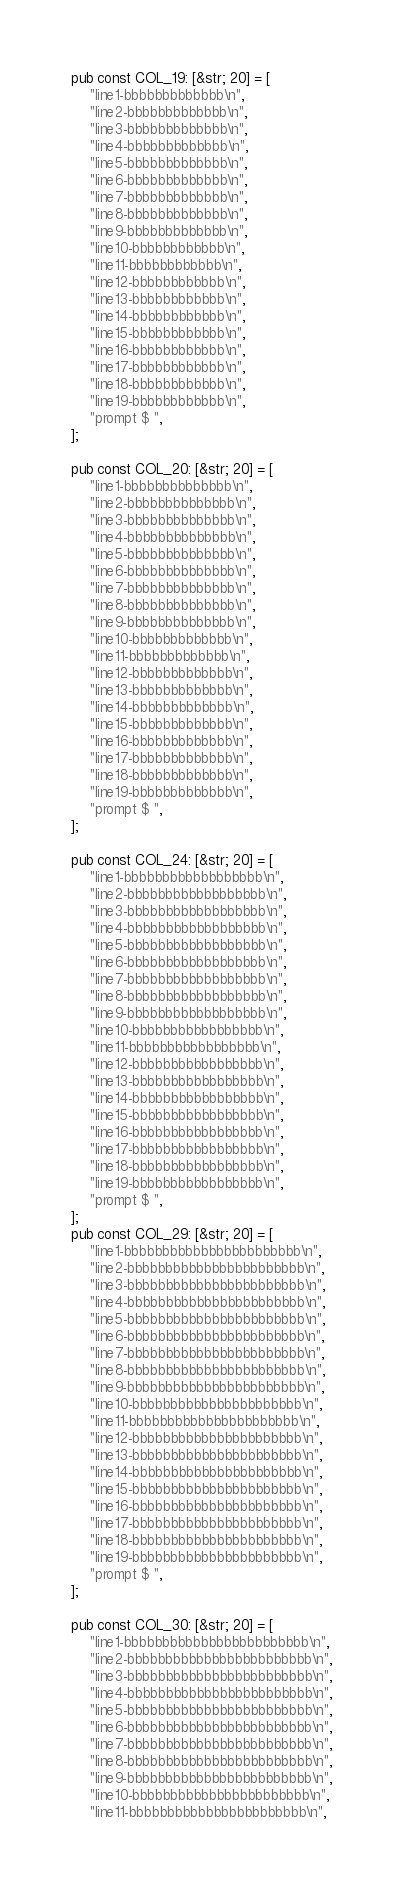<code> <loc_0><loc_0><loc_500><loc_500><_Rust_>
pub const COL_19: [&str; 20] = [
    "line1-bbbbbbbbbbbbb\n",
    "line2-bbbbbbbbbbbbb\n",
    "line3-bbbbbbbbbbbbb\n",
    "line4-bbbbbbbbbbbbb\n",
    "line5-bbbbbbbbbbbbb\n",
    "line6-bbbbbbbbbbbbb\n",
    "line7-bbbbbbbbbbbbb\n",
    "line8-bbbbbbbbbbbbb\n",
    "line9-bbbbbbbbbbbbb\n",
    "line10-bbbbbbbbbbbb\n",
    "line11-bbbbbbbbbbbb\n",
    "line12-bbbbbbbbbbbb\n",
    "line13-bbbbbbbbbbbb\n",
    "line14-bbbbbbbbbbbb\n",
    "line15-bbbbbbbbbbbb\n",
    "line16-bbbbbbbbbbbb\n",
    "line17-bbbbbbbbbbbb\n",
    "line18-bbbbbbbbbbbb\n",
    "line19-bbbbbbbbbbbb\n",
    "prompt $ ",
];

pub const COL_20: [&str; 20] = [
    "line1-bbbbbbbbbbbbbb\n",
    "line2-bbbbbbbbbbbbbb\n",
    "line3-bbbbbbbbbbbbbb\n",
    "line4-bbbbbbbbbbbbbb\n",
    "line5-bbbbbbbbbbbbbb\n",
    "line6-bbbbbbbbbbbbbb\n",
    "line7-bbbbbbbbbbbbbb\n",
    "line8-bbbbbbbbbbbbbb\n",
    "line9-bbbbbbbbbbbbbb\n",
    "line10-bbbbbbbbbbbbb\n",
    "line11-bbbbbbbbbbbbb\n",
    "line12-bbbbbbbbbbbbb\n",
    "line13-bbbbbbbbbbbbb\n",
    "line14-bbbbbbbbbbbbb\n",
    "line15-bbbbbbbbbbbbb\n",
    "line16-bbbbbbbbbbbbb\n",
    "line17-bbbbbbbbbbbbb\n",
    "line18-bbbbbbbbbbbbb\n",
    "line19-bbbbbbbbbbbbb\n",
    "prompt $ ",
];

pub const COL_24: [&str; 20] = [
    "line1-bbbbbbbbbbbbbbbbbb\n",
    "line2-bbbbbbbbbbbbbbbbbb\n",
    "line3-bbbbbbbbbbbbbbbbbb\n",
    "line4-bbbbbbbbbbbbbbbbbb\n",
    "line5-bbbbbbbbbbbbbbbbbb\n",
    "line6-bbbbbbbbbbbbbbbbbb\n",
    "line7-bbbbbbbbbbbbbbbbbb\n",
    "line8-bbbbbbbbbbbbbbbbbb\n",
    "line9-bbbbbbbbbbbbbbbbbb\n",
    "line10-bbbbbbbbbbbbbbbbb\n",
    "line11-bbbbbbbbbbbbbbbbb\n",
    "line12-bbbbbbbbbbbbbbbbb\n",
    "line13-bbbbbbbbbbbbbbbbb\n",
    "line14-bbbbbbbbbbbbbbbbb\n",
    "line15-bbbbbbbbbbbbbbbbb\n",
    "line16-bbbbbbbbbbbbbbbbb\n",
    "line17-bbbbbbbbbbbbbbbbb\n",
    "line18-bbbbbbbbbbbbbbbbb\n",
    "line19-bbbbbbbbbbbbbbbbb\n",
    "prompt $ ",
];
pub const COL_29: [&str; 20] = [
    "line1-bbbbbbbbbbbbbbbbbbbbbbb\n",
    "line2-bbbbbbbbbbbbbbbbbbbbbbb\n",
    "line3-bbbbbbbbbbbbbbbbbbbbbbb\n",
    "line4-bbbbbbbbbbbbbbbbbbbbbbb\n",
    "line5-bbbbbbbbbbbbbbbbbbbbbbb\n",
    "line6-bbbbbbbbbbbbbbbbbbbbbbb\n",
    "line7-bbbbbbbbbbbbbbbbbbbbbbb\n",
    "line8-bbbbbbbbbbbbbbbbbbbbbbb\n",
    "line9-bbbbbbbbbbbbbbbbbbbbbbb\n",
    "line10-bbbbbbbbbbbbbbbbbbbbbb\n",
    "line11-bbbbbbbbbbbbbbbbbbbbbb\n",
    "line12-bbbbbbbbbbbbbbbbbbbbbb\n",
    "line13-bbbbbbbbbbbbbbbbbbbbbb\n",
    "line14-bbbbbbbbbbbbbbbbbbbbbb\n",
    "line15-bbbbbbbbbbbbbbbbbbbbbb\n",
    "line16-bbbbbbbbbbbbbbbbbbbbbb\n",
    "line17-bbbbbbbbbbbbbbbbbbbbbb\n",
    "line18-bbbbbbbbbbbbbbbbbbbbbb\n",
    "line19-bbbbbbbbbbbbbbbbbbbbbb\n",
    "prompt $ ",
];

pub const COL_30: [&str; 20] = [
    "line1-bbbbbbbbbbbbbbbbbbbbbbbb\n",
    "line2-bbbbbbbbbbbbbbbbbbbbbbbb\n",
    "line3-bbbbbbbbbbbbbbbbbbbbbbbb\n",
    "line4-bbbbbbbbbbbbbbbbbbbbbbbb\n",
    "line5-bbbbbbbbbbbbbbbbbbbbbbbb\n",
    "line6-bbbbbbbbbbbbbbbbbbbbbbbb\n",
    "line7-bbbbbbbbbbbbbbbbbbbbbbbb\n",
    "line8-bbbbbbbbbbbbbbbbbbbbbbbb\n",
    "line9-bbbbbbbbbbbbbbbbbbbbbbbb\n",
    "line10-bbbbbbbbbbbbbbbbbbbbbbb\n",
    "line11-bbbbbbbbbbbbbbbbbbbbbbb\n",</code> 